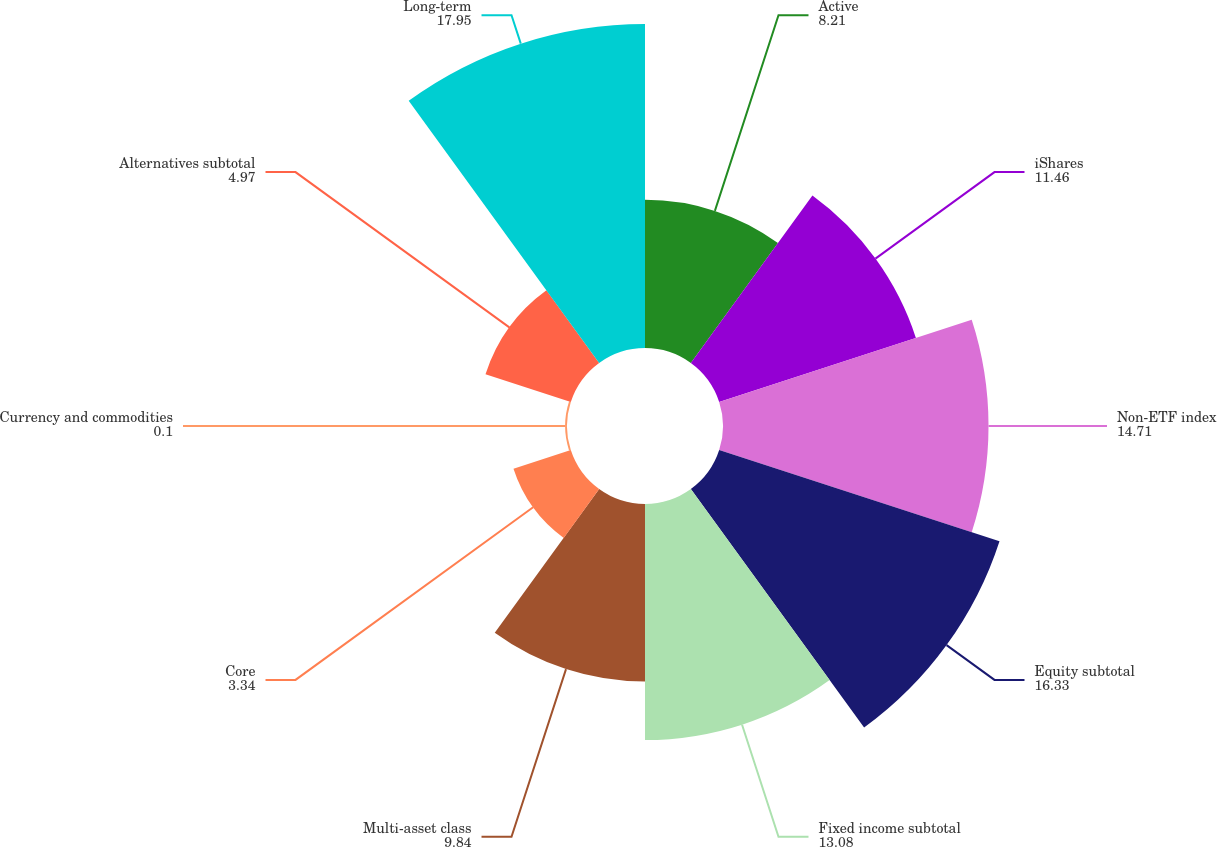<chart> <loc_0><loc_0><loc_500><loc_500><pie_chart><fcel>Active<fcel>iShares<fcel>Non-ETF index<fcel>Equity subtotal<fcel>Fixed income subtotal<fcel>Multi-asset class<fcel>Core<fcel>Currency and commodities<fcel>Alternatives subtotal<fcel>Long-term<nl><fcel>8.21%<fcel>11.46%<fcel>14.71%<fcel>16.33%<fcel>13.08%<fcel>9.84%<fcel>3.34%<fcel>0.1%<fcel>4.97%<fcel>17.95%<nl></chart> 